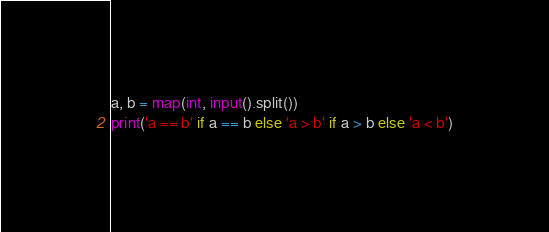<code> <loc_0><loc_0><loc_500><loc_500><_Python_>a, b = map(int, input().split())
print('a == b' if a == b else 'a > b' if a > b else 'a < b')</code> 